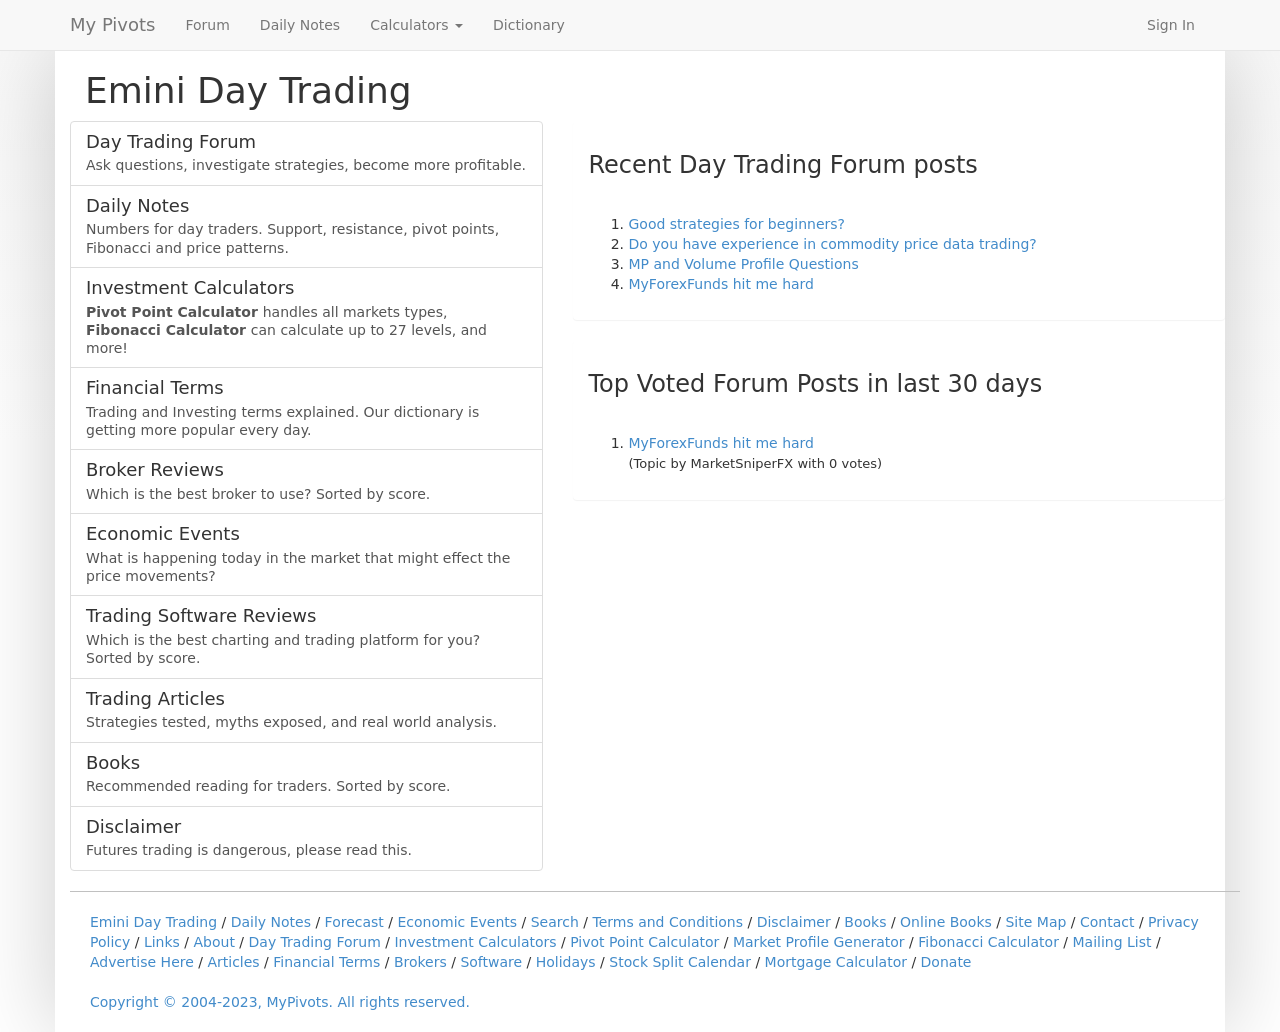Could you guide me through the process of developing this website with HTML? To develop a website similar to the one shown in the image, you can start by structuring your HTML to include sections for a Day Trading Forum, Daily Notes, Investment Calculators, and more. Use <div> tags to create distinct sections and <h1> to <h6> for headings. Incorporate forms for user interaction and links for navigation within the site. Apply CSS for styling to make the layout appealing and responsive. Make sure to also plan for backend support if the site involves real-time data or user interactions. 